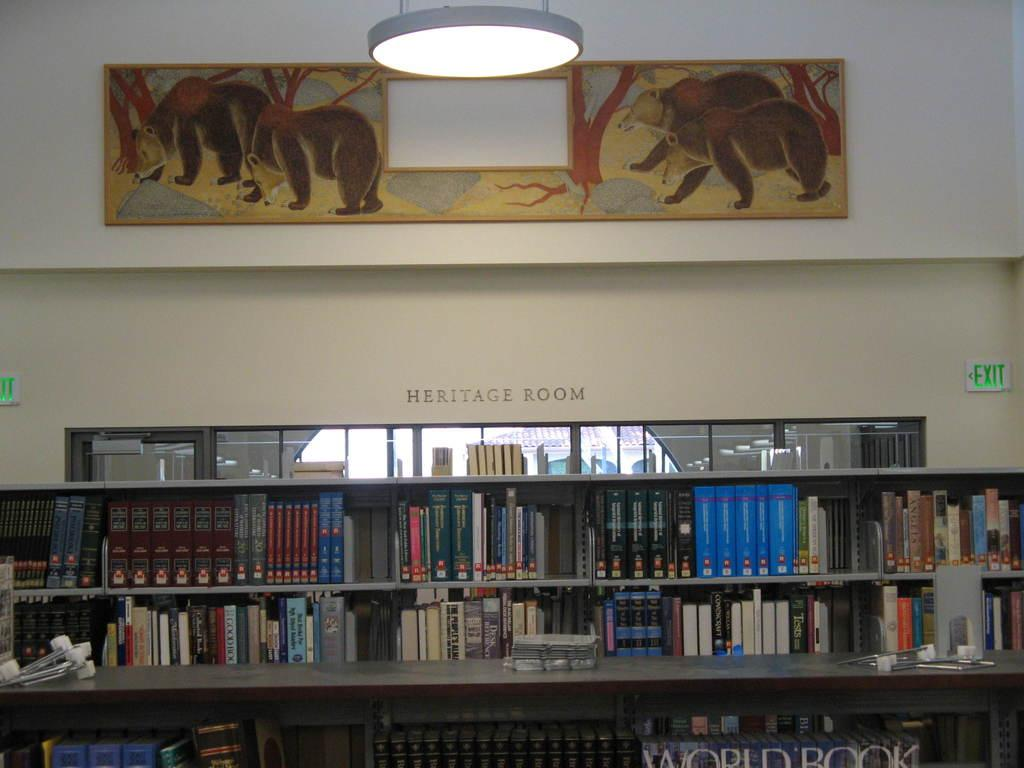<image>
Share a concise interpretation of the image provided. A book shelf full of books in the Heritage Room of a library. 